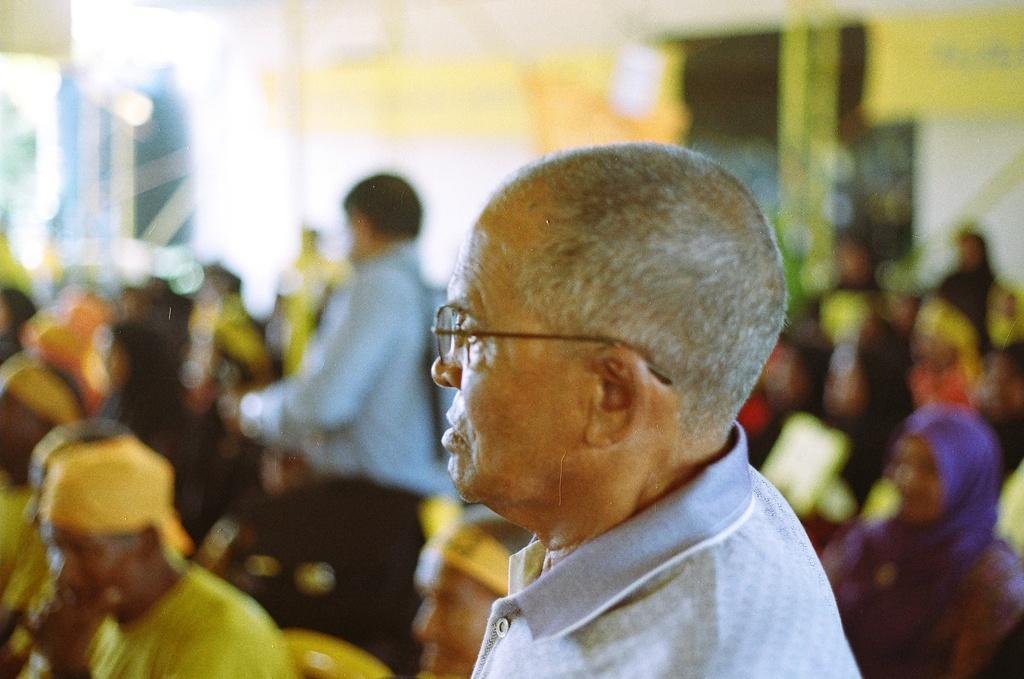What is the person in the image wearing on their face? The person in the image is wearing spectacles. What are the people in the image doing? There is a group of people sitting in the image. Can you describe the position of one of the individuals in the image? There is a man standing in the image. What type of flame can be seen coming from the guitar in the image? There is no guitar or flame present in the image. What is the person writing on in the image? There is no writing or writing instrument present in the image. 